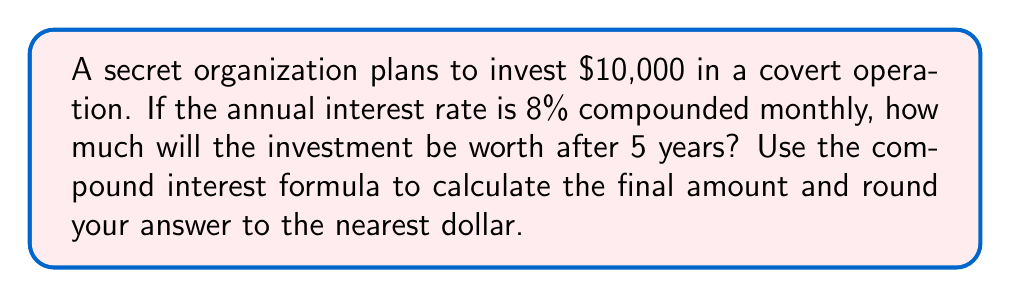Show me your answer to this math problem. To solve this problem, we'll use the compound interest formula:

$$A = P(1 + \frac{r}{n})^{nt}$$

Where:
$A$ = final amount
$P$ = principal (initial investment)
$r$ = annual interest rate (as a decimal)
$n$ = number of times interest is compounded per year
$t$ = number of years

Given:
$P = 10000$
$r = 0.08$ (8% as a decimal)
$n = 12$ (compounded monthly)
$t = 5$ years

Let's substitute these values into the formula:

$$A = 10000(1 + \frac{0.08}{12})^{12 \cdot 5}$$

$$A = 10000(1 + 0.00667)^{60}$$

$$A = 10000(1.00667)^{60}$$

Using a calculator:

$$A = 10000 \cdot 1.4859$$

$$A = 14859.47$$

Rounding to the nearest dollar:

$$A = 14859$$
Answer: $14859 